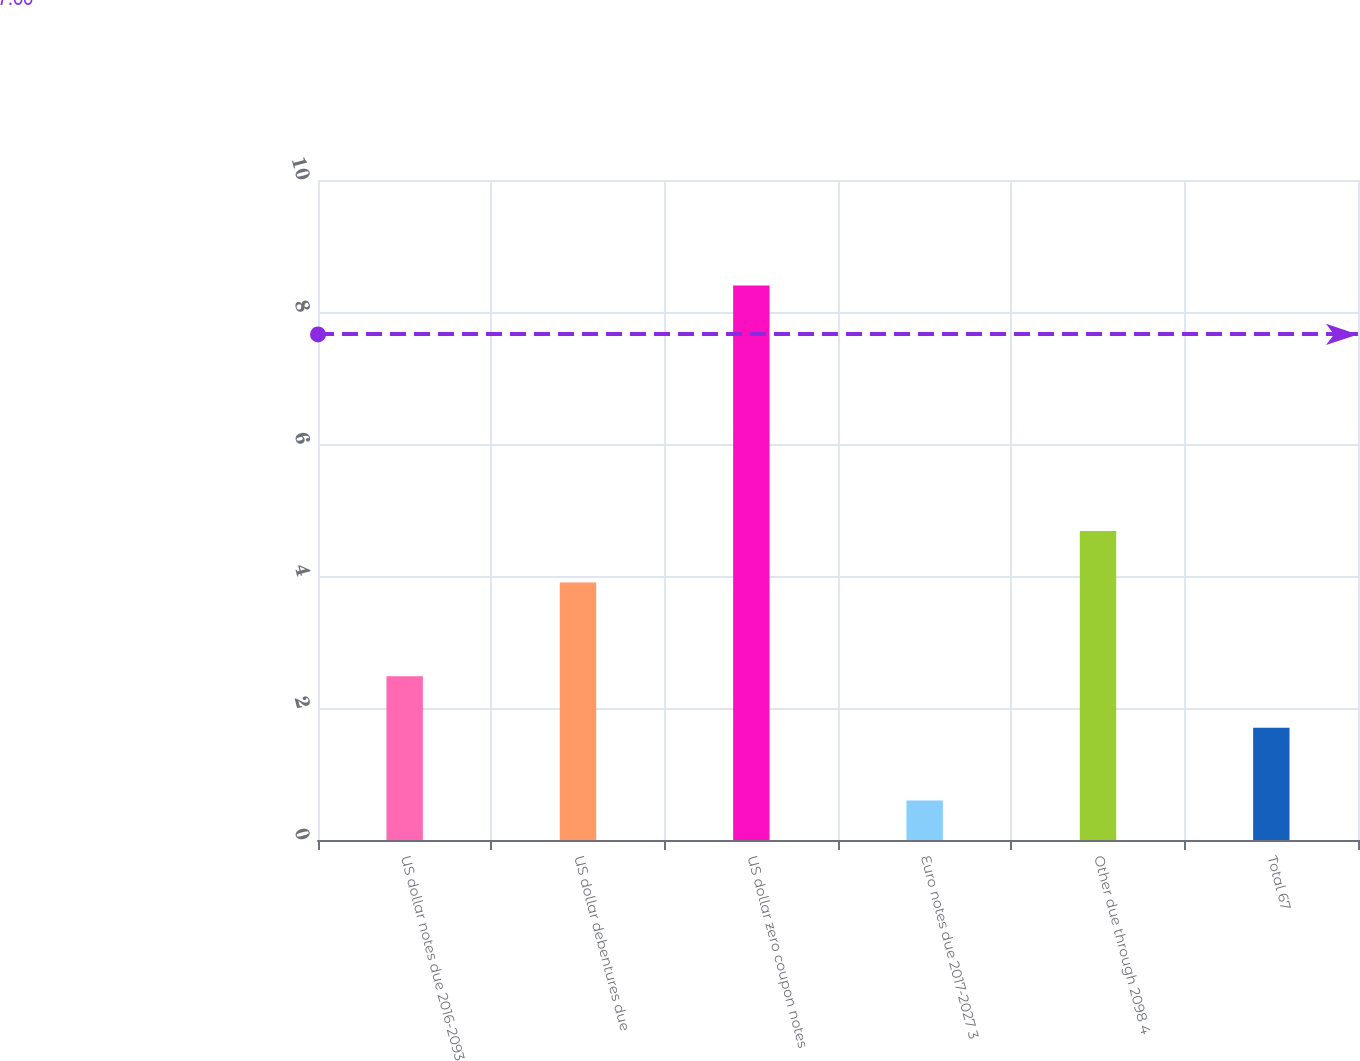<chart> <loc_0><loc_0><loc_500><loc_500><bar_chart><fcel>US dollar notes due 2016-2093<fcel>US dollar debentures due<fcel>US dollar zero coupon notes<fcel>Euro notes due 2017-2027 3<fcel>Other due through 2098 4<fcel>Total 67<nl><fcel>2.48<fcel>3.9<fcel>8.4<fcel>0.6<fcel>4.68<fcel>1.7<nl></chart> 